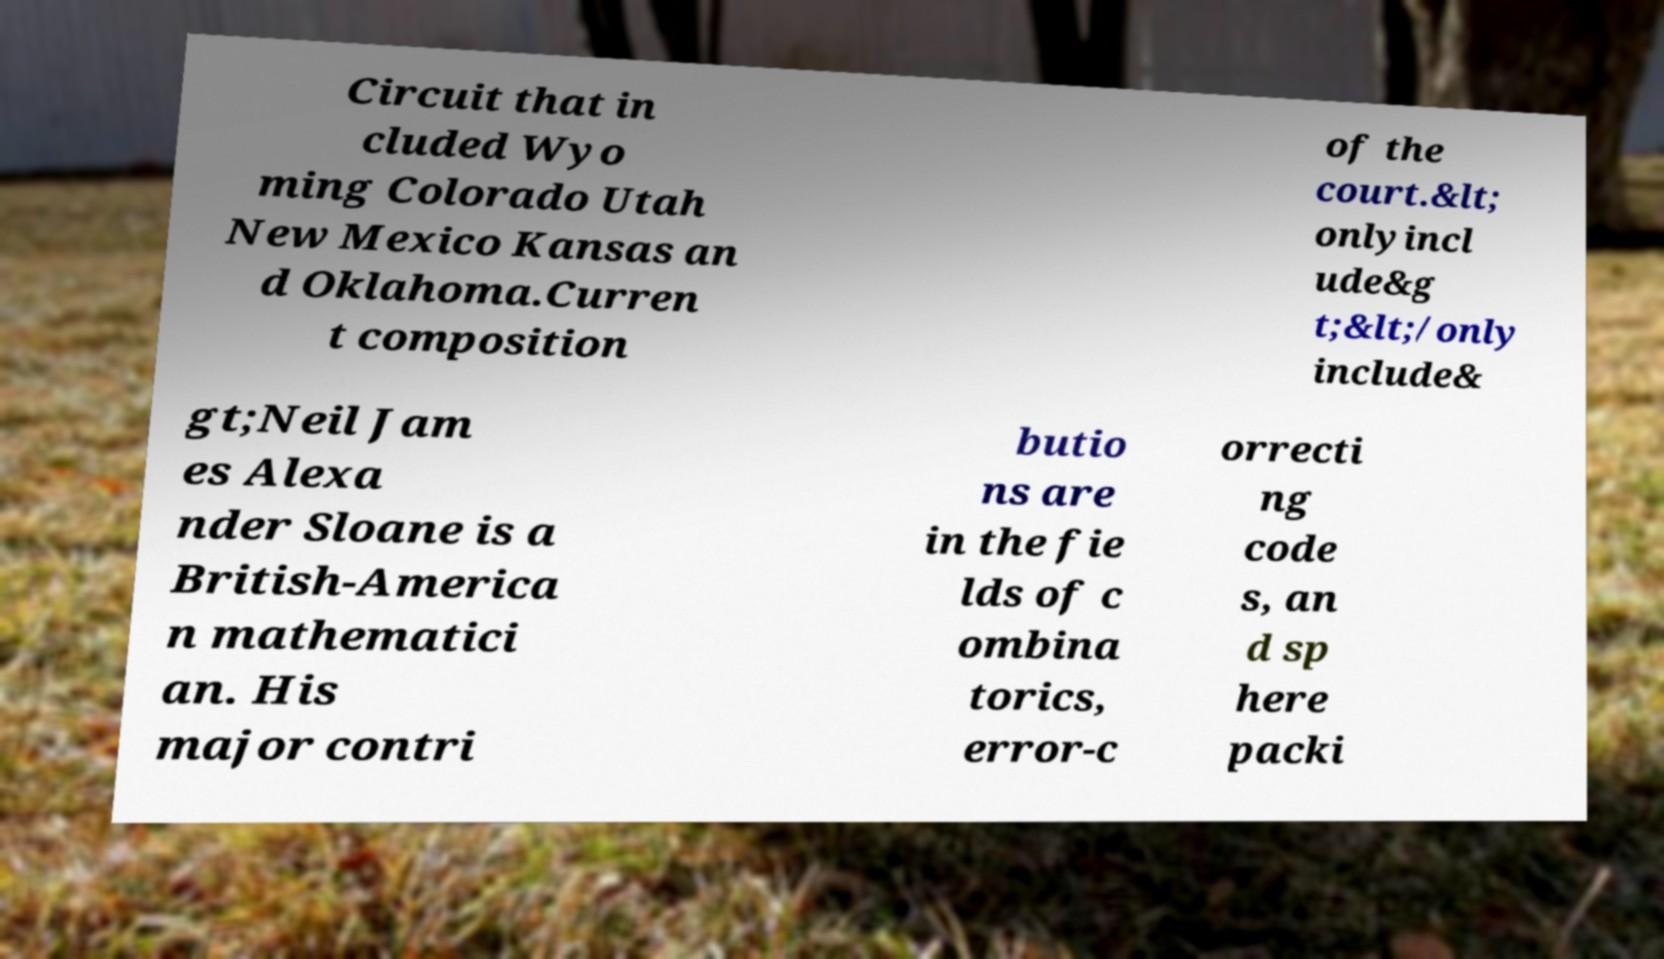Please identify and transcribe the text found in this image. Circuit that in cluded Wyo ming Colorado Utah New Mexico Kansas an d Oklahoma.Curren t composition of the court.&lt; onlyincl ude&g t;&lt;/only include& gt;Neil Jam es Alexa nder Sloane is a British-America n mathematici an. His major contri butio ns are in the fie lds of c ombina torics, error-c orrecti ng code s, an d sp here packi 